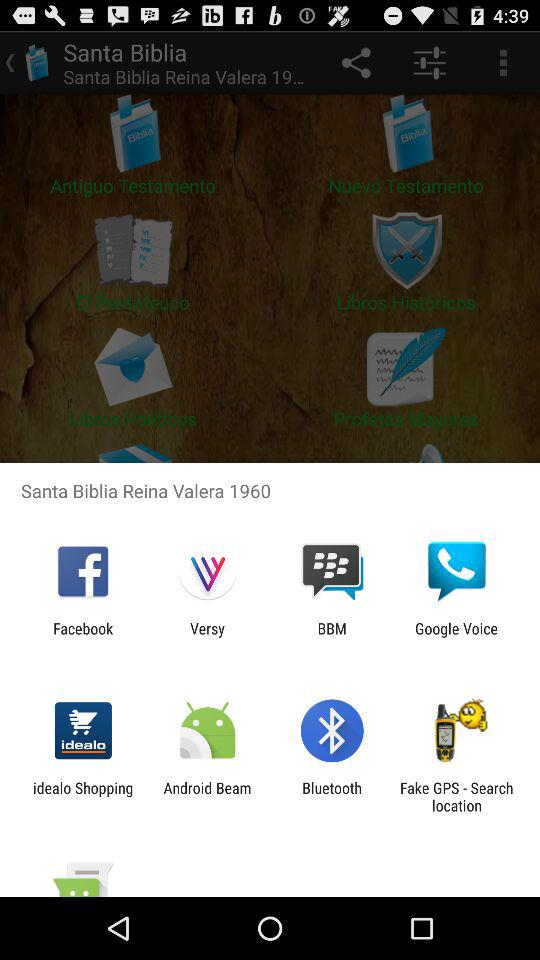Who is this application powered by?
When the provided information is insufficient, respond with <no answer>. <no answer> 